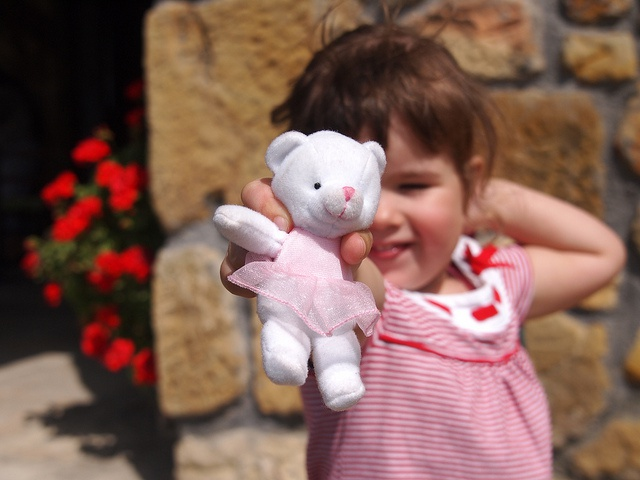Describe the objects in this image and their specific colors. I can see people in black, lightpink, brown, and maroon tones, teddy bear in black, lavender, darkgray, pink, and gray tones, and potted plant in black, maroon, and brown tones in this image. 